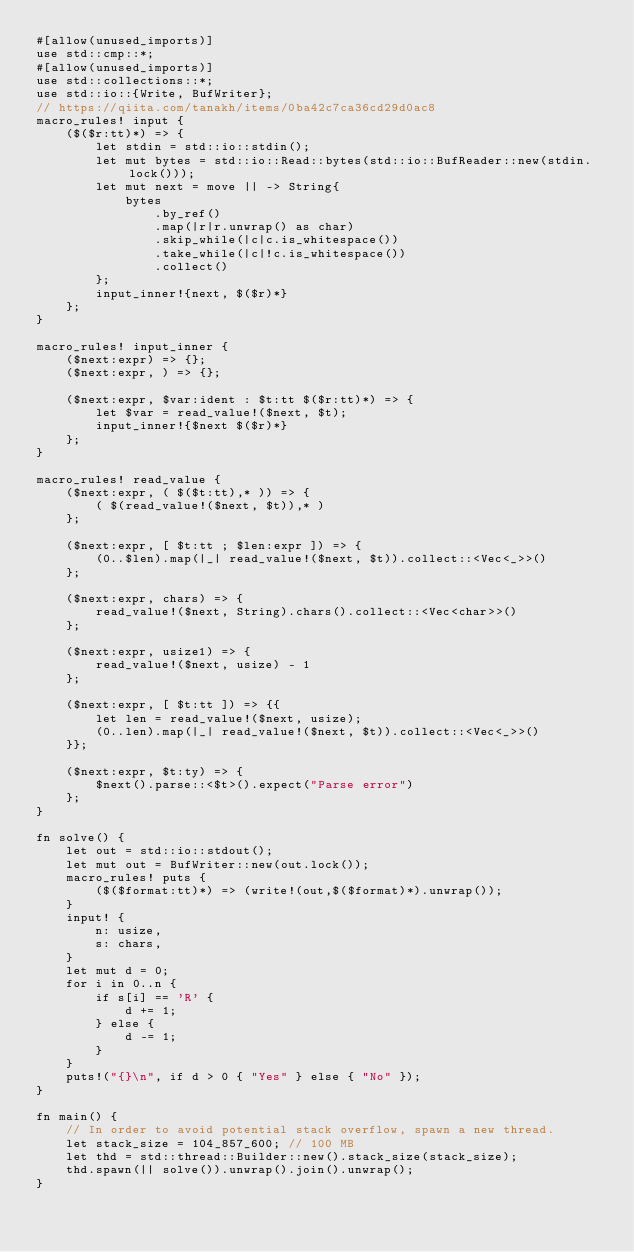Convert code to text. <code><loc_0><loc_0><loc_500><loc_500><_Rust_>#[allow(unused_imports)]
use std::cmp::*;
#[allow(unused_imports)]
use std::collections::*;
use std::io::{Write, BufWriter};
// https://qiita.com/tanakh/items/0ba42c7ca36cd29d0ac8
macro_rules! input {
    ($($r:tt)*) => {
        let stdin = std::io::stdin();
        let mut bytes = std::io::Read::bytes(std::io::BufReader::new(stdin.lock()));
        let mut next = move || -> String{
            bytes
                .by_ref()
                .map(|r|r.unwrap() as char)
                .skip_while(|c|c.is_whitespace())
                .take_while(|c|!c.is_whitespace())
                .collect()
        };
        input_inner!{next, $($r)*}
    };
}

macro_rules! input_inner {
    ($next:expr) => {};
    ($next:expr, ) => {};

    ($next:expr, $var:ident : $t:tt $($r:tt)*) => {
        let $var = read_value!($next, $t);
        input_inner!{$next $($r)*}
    };
}

macro_rules! read_value {
    ($next:expr, ( $($t:tt),* )) => {
        ( $(read_value!($next, $t)),* )
    };

    ($next:expr, [ $t:tt ; $len:expr ]) => {
        (0..$len).map(|_| read_value!($next, $t)).collect::<Vec<_>>()
    };

    ($next:expr, chars) => {
        read_value!($next, String).chars().collect::<Vec<char>>()
    };

    ($next:expr, usize1) => {
        read_value!($next, usize) - 1
    };

    ($next:expr, [ $t:tt ]) => {{
        let len = read_value!($next, usize);
        (0..len).map(|_| read_value!($next, $t)).collect::<Vec<_>>()
    }};

    ($next:expr, $t:ty) => {
        $next().parse::<$t>().expect("Parse error")
    };
}

fn solve() {
    let out = std::io::stdout();
    let mut out = BufWriter::new(out.lock());
    macro_rules! puts {
        ($($format:tt)*) => (write!(out,$($format)*).unwrap());
    }
    input! {
        n: usize,
        s: chars,
    }
    let mut d = 0;
    for i in 0..n {
        if s[i] == 'R' {
            d += 1;
        } else {
            d -= 1;
        }
    }
    puts!("{}\n", if d > 0 { "Yes" } else { "No" });
}

fn main() {
    // In order to avoid potential stack overflow, spawn a new thread.
    let stack_size = 104_857_600; // 100 MB
    let thd = std::thread::Builder::new().stack_size(stack_size);
    thd.spawn(|| solve()).unwrap().join().unwrap();
}
</code> 